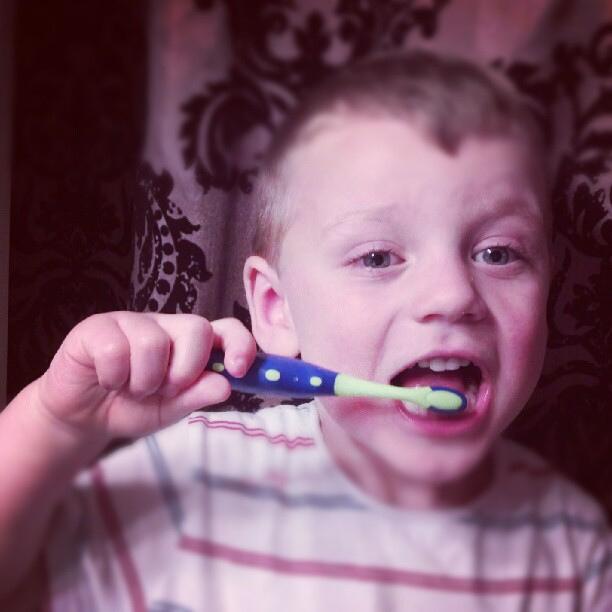What sort of pattern is on the curtain?
Answer briefly. Paisley. What color are the boy's eyebrows?
Keep it brief. Blonde. How many teeth does the boy have?
Keep it brief. 7. 